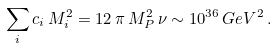Convert formula to latex. <formula><loc_0><loc_0><loc_500><loc_500>\sum _ { i } c _ { i } \, M _ { i } ^ { 2 } = 1 2 \, \pi \, M _ { P } ^ { 2 } \, \nu \sim 1 0 ^ { 3 6 } \, G e V ^ { 2 } \, .</formula> 